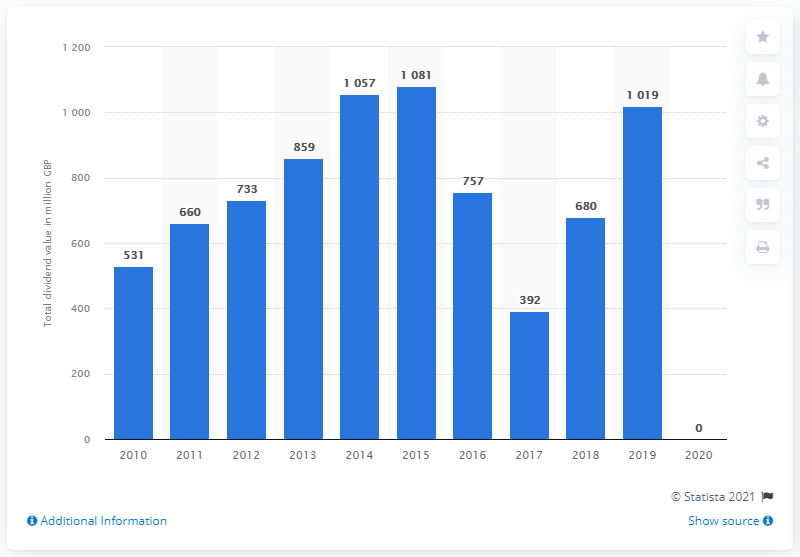Specify some key components in this picture. In the year 2020, no dividends were paid. 